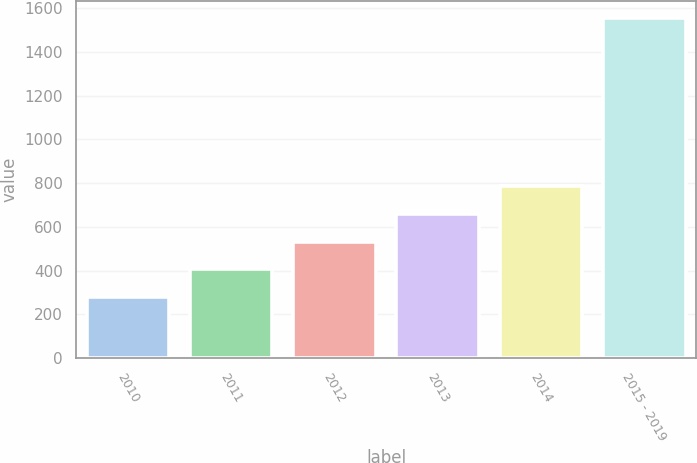<chart> <loc_0><loc_0><loc_500><loc_500><bar_chart><fcel>2010<fcel>2011<fcel>2012<fcel>2013<fcel>2014<fcel>2015 - 2019<nl><fcel>278<fcel>405.7<fcel>533.4<fcel>661.1<fcel>788.8<fcel>1555<nl></chart> 